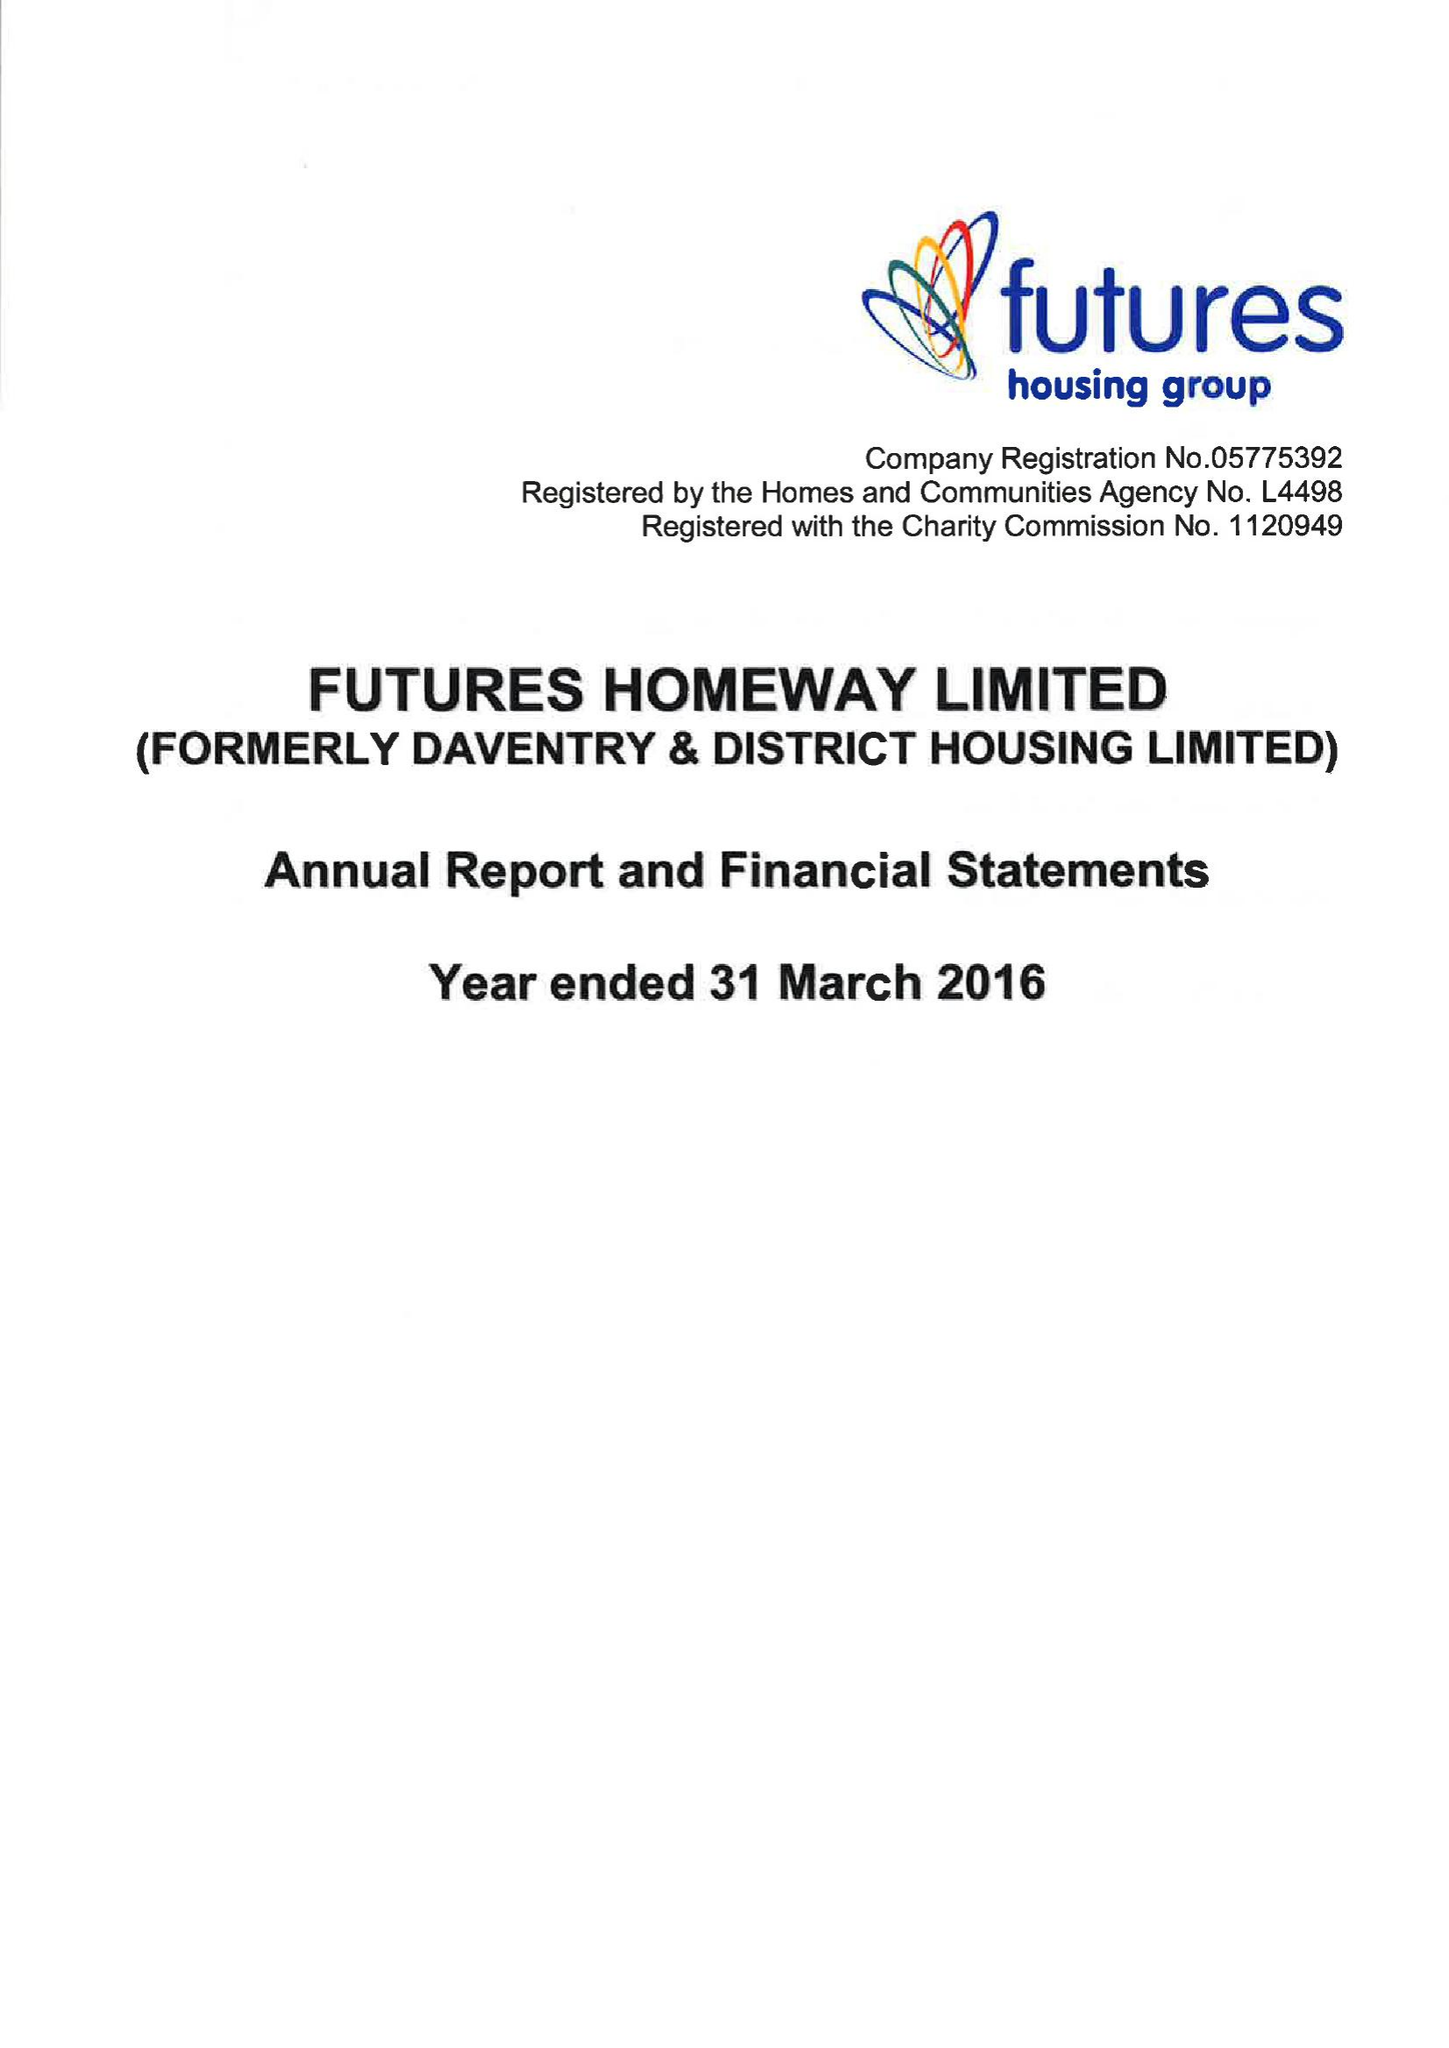What is the value for the spending_annually_in_british_pounds?
Answer the question using a single word or phrase. 13835000.00 